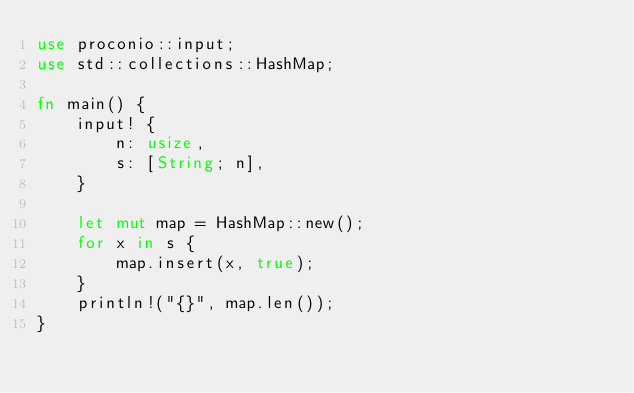Convert code to text. <code><loc_0><loc_0><loc_500><loc_500><_Rust_>use proconio::input;
use std::collections::HashMap;

fn main() {
    input! {
        n: usize,
        s: [String; n],
    }

    let mut map = HashMap::new();
    for x in s {
        map.insert(x, true);
    }
    println!("{}", map.len());
}
</code> 